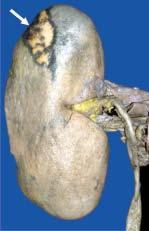what is on the surface?
Answer the question using a single word or phrase. The wedge-shaped infarct 